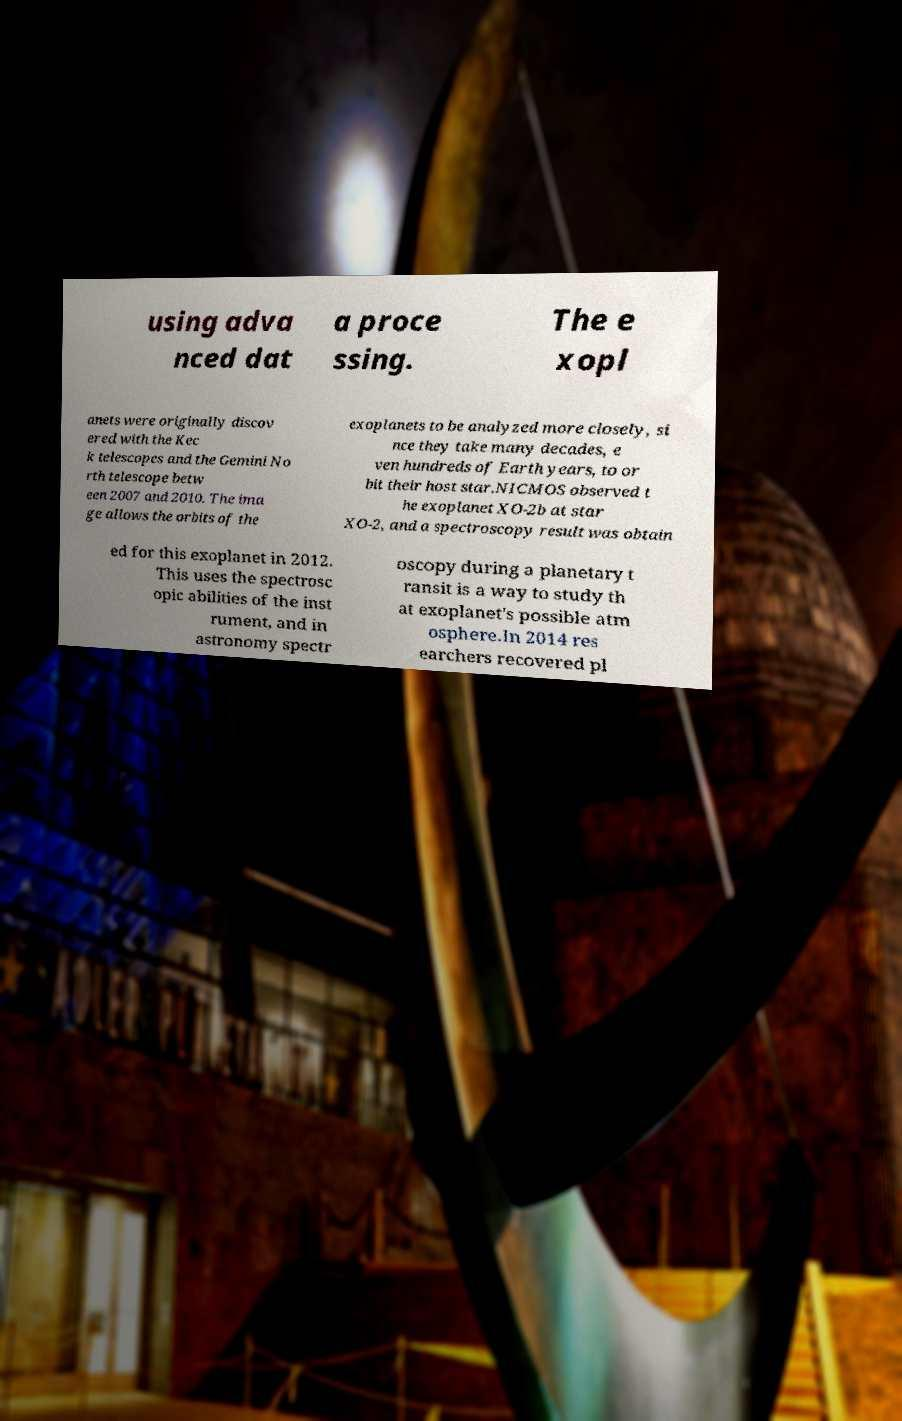Please identify and transcribe the text found in this image. using adva nced dat a proce ssing. The e xopl anets were originally discov ered with the Kec k telescopes and the Gemini No rth telescope betw een 2007 and 2010. The ima ge allows the orbits of the exoplanets to be analyzed more closely, si nce they take many decades, e ven hundreds of Earth years, to or bit their host star.NICMOS observed t he exoplanet XO-2b at star XO-2, and a spectroscopy result was obtain ed for this exoplanet in 2012. This uses the spectrosc opic abilities of the inst rument, and in astronomy spectr oscopy during a planetary t ransit is a way to study th at exoplanet's possible atm osphere.In 2014 res earchers recovered pl 